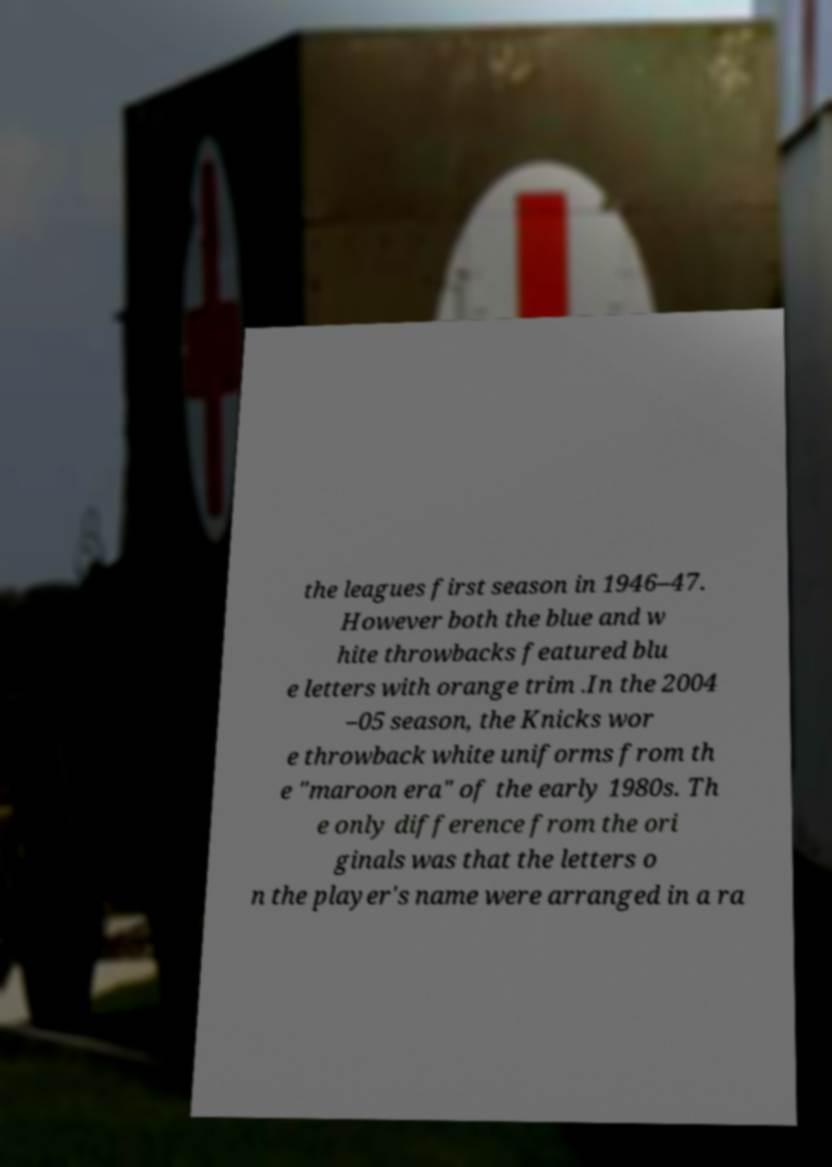There's text embedded in this image that I need extracted. Can you transcribe it verbatim? the leagues first season in 1946–47. However both the blue and w hite throwbacks featured blu e letters with orange trim .In the 2004 –05 season, the Knicks wor e throwback white uniforms from th e "maroon era" of the early 1980s. Th e only difference from the ori ginals was that the letters o n the player's name were arranged in a ra 